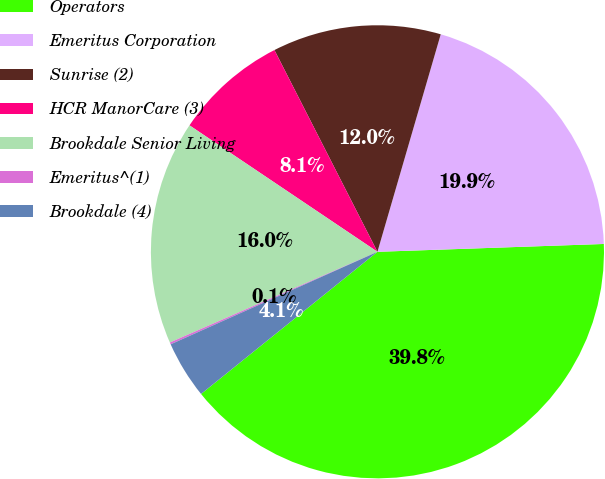<chart> <loc_0><loc_0><loc_500><loc_500><pie_chart><fcel>Operators<fcel>Emeritus Corporation<fcel>Sunrise (2)<fcel>HCR ManorCare (3)<fcel>Brookdale Senior Living<fcel>Emeritus^(1)<fcel>Brookdale (4)<nl><fcel>39.75%<fcel>19.94%<fcel>12.02%<fcel>8.06%<fcel>15.98%<fcel>0.14%<fcel>4.1%<nl></chart> 